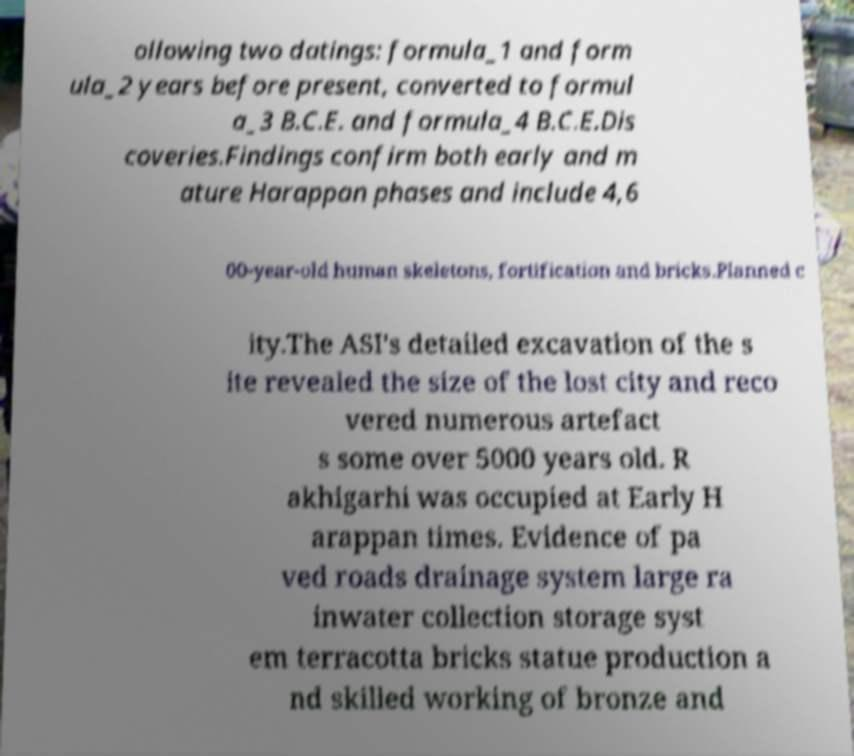Can you read and provide the text displayed in the image?This photo seems to have some interesting text. Can you extract and type it out for me? ollowing two datings: formula_1 and form ula_2 years before present, converted to formul a_3 B.C.E. and formula_4 B.C.E.Dis coveries.Findings confirm both early and m ature Harappan phases and include 4,6 00-year-old human skeletons, fortification and bricks.Planned c ity.The ASI's detailed excavation of the s ite revealed the size of the lost city and reco vered numerous artefact s some over 5000 years old. R akhigarhi was occupied at Early H arappan times. Evidence of pa ved roads drainage system large ra inwater collection storage syst em terracotta bricks statue production a nd skilled working of bronze and 